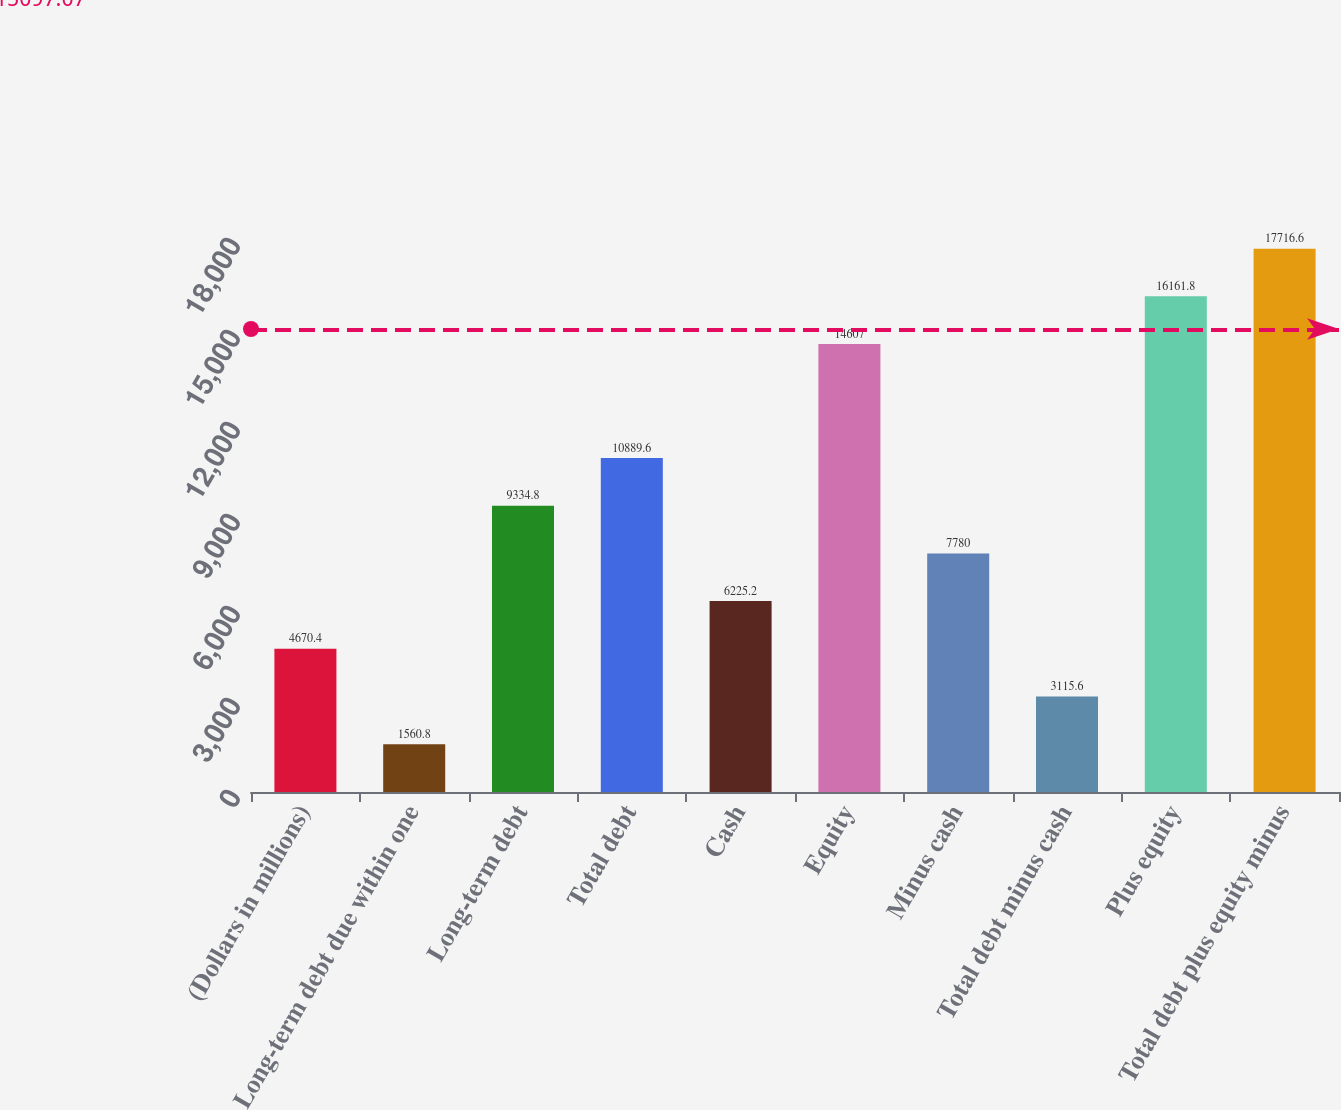Convert chart to OTSL. <chart><loc_0><loc_0><loc_500><loc_500><bar_chart><fcel>(Dollars in millions)<fcel>Long-term debt due within one<fcel>Long-term debt<fcel>Total debt<fcel>Cash<fcel>Equity<fcel>Minus cash<fcel>Total debt minus cash<fcel>Plus equity<fcel>Total debt plus equity minus<nl><fcel>4670.4<fcel>1560.8<fcel>9334.8<fcel>10889.6<fcel>6225.2<fcel>14607<fcel>7780<fcel>3115.6<fcel>16161.8<fcel>17716.6<nl></chart> 